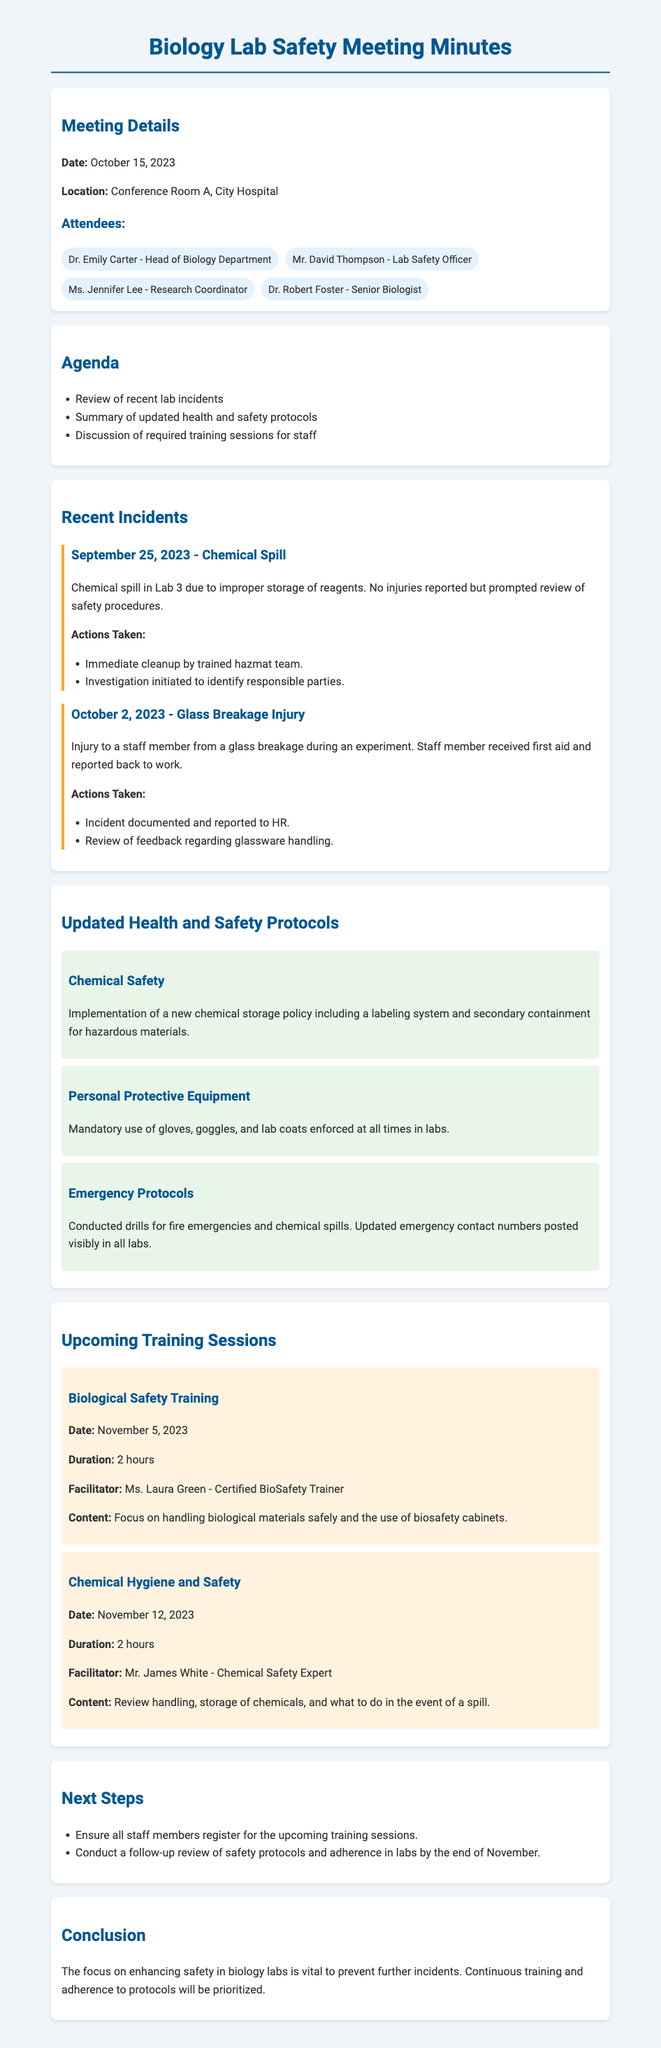what is the date of the meeting? The date of the meeting is mentioned in the Meeting Details section.
Answer: October 15, 2023 who facilitated the Biological Safety Training session? The facilitator for the Biological Safety Training is stated in the Upcoming Training Sessions section.
Answer: Ms. Laura Green how many hours is the Chemical Hygiene and Safety training session? The duration of the Chemical Hygiene and Safety training is specified in the Upcoming Training Sessions section.
Answer: 2 hours what incident occurred on October 2, 2023? The details of the incident on October 2, 2023 are found in the Recent Incidents section.
Answer: Glass Breakage Injury what is one of the actions taken after the chemical spill incident? Actions taken after the chemical spill are listed in the Recent Incidents section.
Answer: Immediate cleanup by trained hazmat team what is the main focus of the updated health and safety protocols? The focus of the updated health and safety protocols is summarized in the Updated Health and Safety Protocols section.
Answer: Enhancing lab safety how will staff members ensure safety protocols are followed? The action planned for following up on safety protocols is mentioned in the Next Steps section.
Answer: Conduct a follow-up review of safety protocols and adherence in labs 